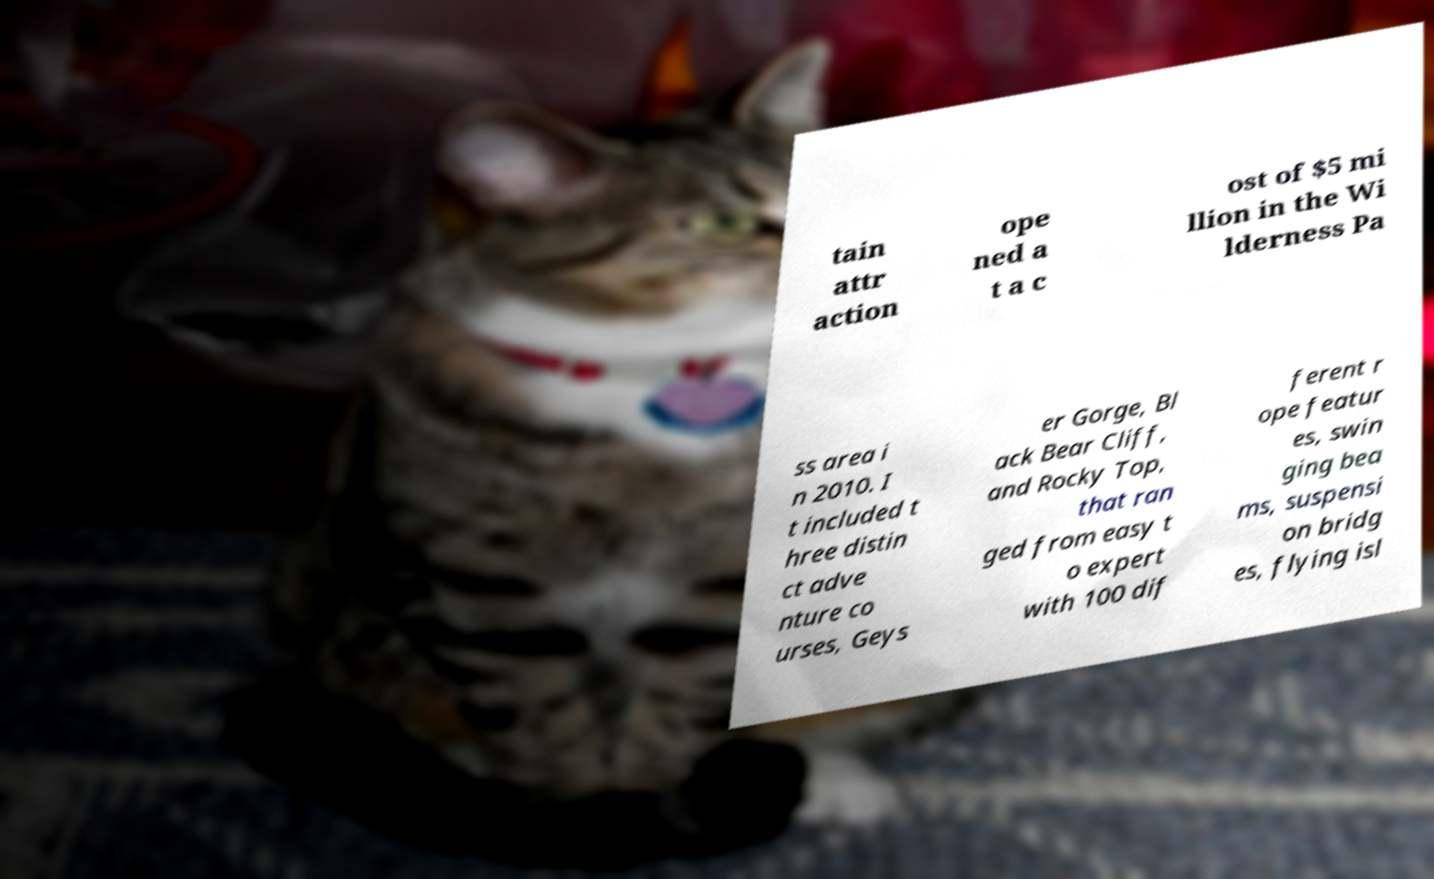For documentation purposes, I need the text within this image transcribed. Could you provide that? tain attr action ope ned a t a c ost of $5 mi llion in the Wi lderness Pa ss area i n 2010. I t included t hree distin ct adve nture co urses, Geys er Gorge, Bl ack Bear Cliff, and Rocky Top, that ran ged from easy t o expert with 100 dif ferent r ope featur es, swin ging bea ms, suspensi on bridg es, flying isl 